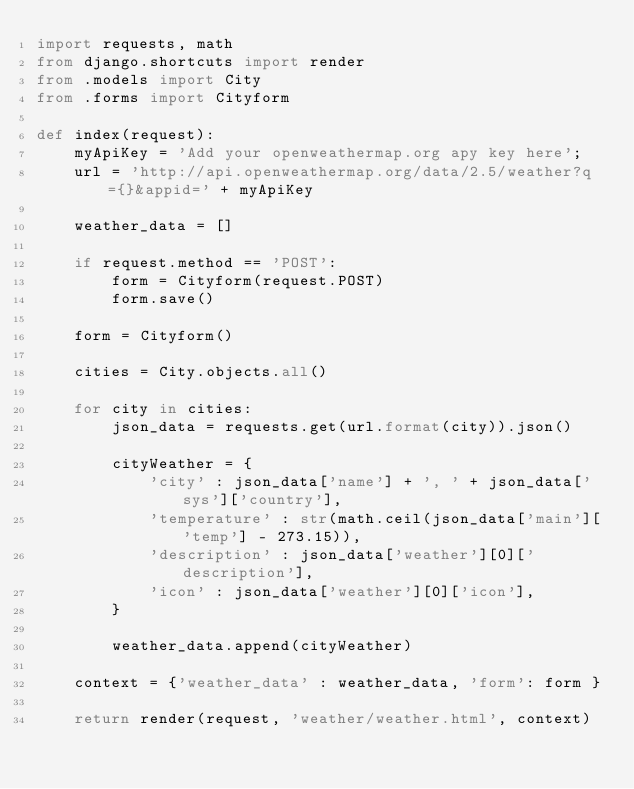Convert code to text. <code><loc_0><loc_0><loc_500><loc_500><_Python_>import requests, math
from django.shortcuts import render
from .models import City
from .forms import Cityform

def index(request):
    myApiKey = 'Add your openweathermap.org apy key here';
    url = 'http://api.openweathermap.org/data/2.5/weather?q={}&appid=' + myApiKey

    weather_data = []

    if request.method == 'POST':
        form = Cityform(request.POST)
        form.save()

    form = Cityform()

    cities = City.objects.all()

    for city in cities:
        json_data = requests.get(url.format(city)).json()

        cityWeather = {
            'city' : json_data['name'] + ', ' + json_data['sys']['country'],
            'temperature' : str(math.ceil(json_data['main']['temp'] - 273.15)),
            'description' : json_data['weather'][0]['description'],
            'icon' : json_data['weather'][0]['icon'],
        }

        weather_data.append(cityWeather)

    context = {'weather_data' : weather_data, 'form': form }

    return render(request, 'weather/weather.html', context)</code> 